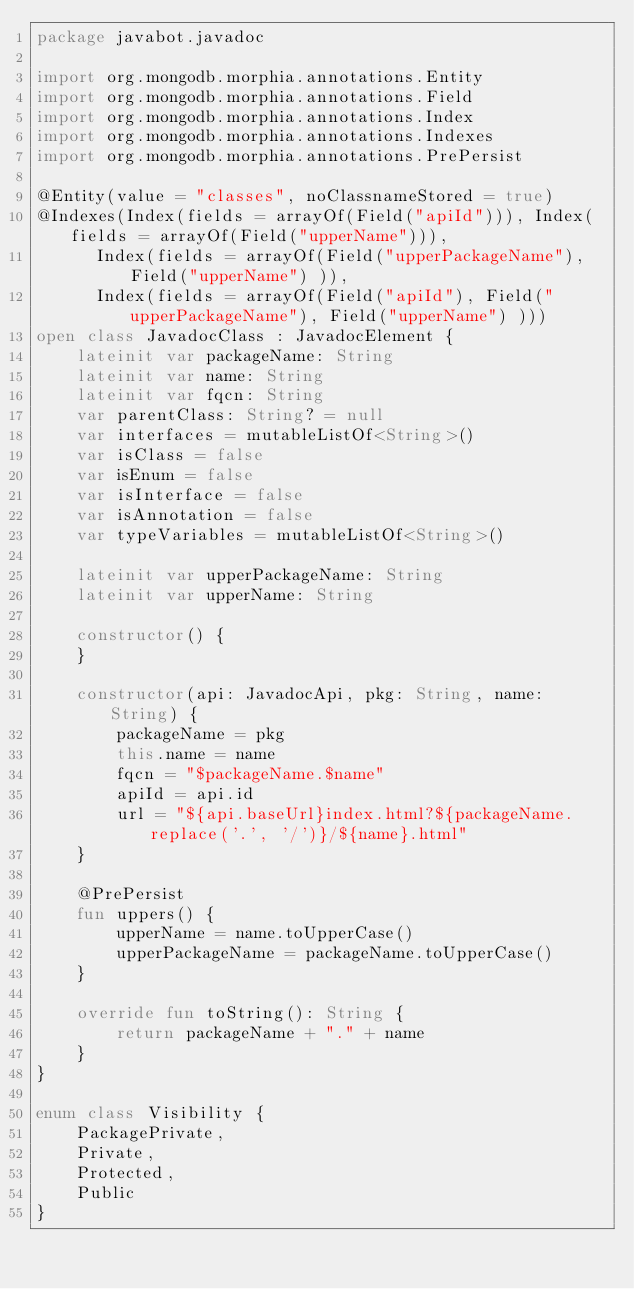<code> <loc_0><loc_0><loc_500><loc_500><_Kotlin_>package javabot.javadoc

import org.mongodb.morphia.annotations.Entity
import org.mongodb.morphia.annotations.Field
import org.mongodb.morphia.annotations.Index
import org.mongodb.morphia.annotations.Indexes
import org.mongodb.morphia.annotations.PrePersist

@Entity(value = "classes", noClassnameStored = true)
@Indexes(Index(fields = arrayOf(Field("apiId"))), Index(fields = arrayOf(Field("upperName"))),
      Index(fields = arrayOf(Field("upperPackageName"), Field("upperName") )),
      Index(fields = arrayOf(Field("apiId"), Field("upperPackageName"), Field("upperName") )))
open class JavadocClass : JavadocElement {
    lateinit var packageName: String
    lateinit var name: String
    lateinit var fqcn: String
    var parentClass: String? = null
    var interfaces = mutableListOf<String>()
    var isClass = false
    var isEnum = false
    var isInterface = false
    var isAnnotation = false
    var typeVariables = mutableListOf<String>()

    lateinit var upperPackageName: String
    lateinit var upperName: String

    constructor() {
    }

    constructor(api: JavadocApi, pkg: String, name: String) {
        packageName = pkg
        this.name = name
        fqcn = "$packageName.$name"
        apiId = api.id
        url = "${api.baseUrl}index.html?${packageName.replace('.', '/')}/${name}.html"
    }

    @PrePersist
    fun uppers() {
        upperName = name.toUpperCase()
        upperPackageName = packageName.toUpperCase()
    }

    override fun toString(): String {
        return packageName + "." + name
    }
}

enum class Visibility {
    PackagePrivate,
    Private,
    Protected,
    Public
}
</code> 